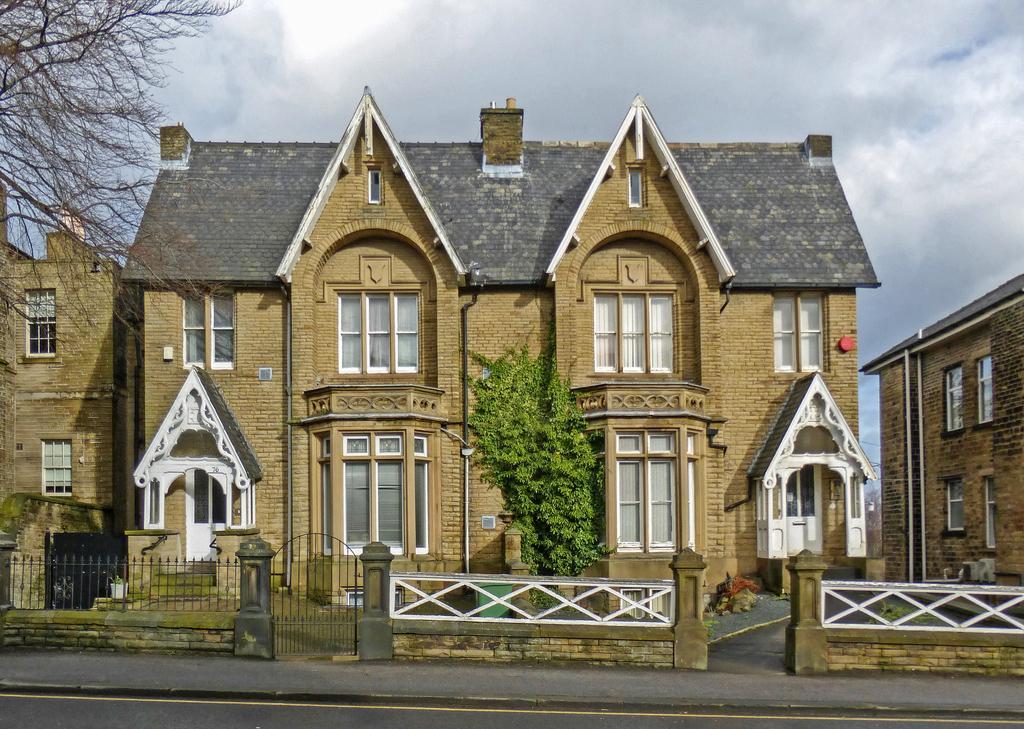Could you give a brief overview of what you see in this image? In this image we can see few buildings with doors and windows and there are few trees and at the top we can see the cloudy sky. 